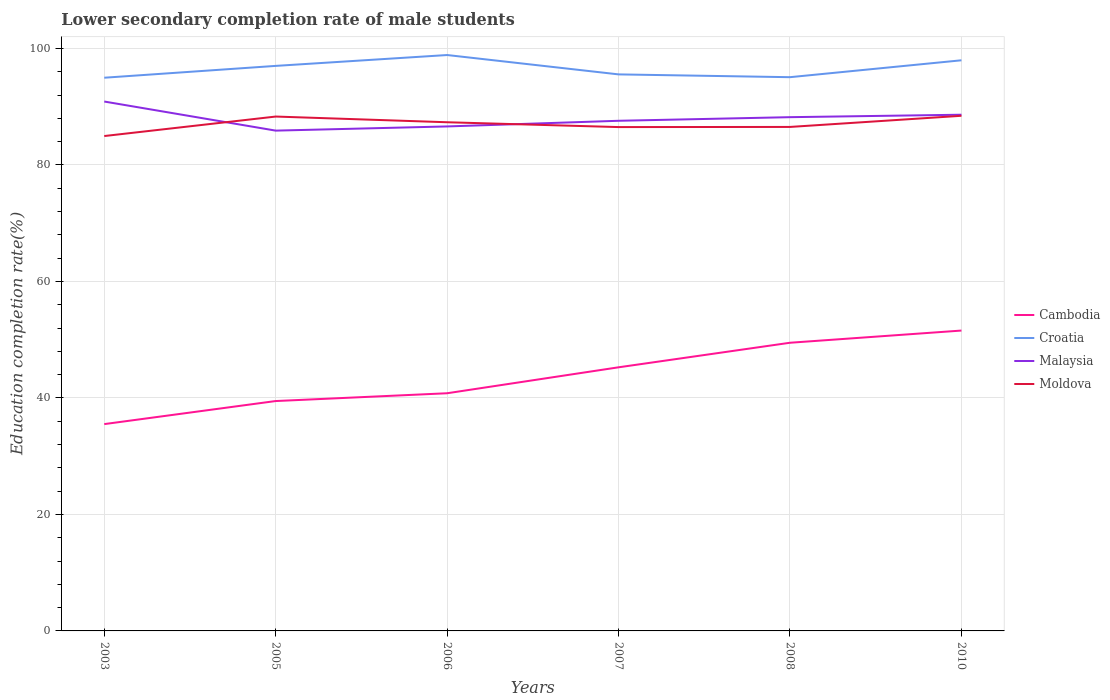How many different coloured lines are there?
Keep it short and to the point. 4. Does the line corresponding to Croatia intersect with the line corresponding to Malaysia?
Give a very brief answer. No. Across all years, what is the maximum lower secondary completion rate of male students in Cambodia?
Keep it short and to the point. 35.51. In which year was the lower secondary completion rate of male students in Croatia maximum?
Provide a short and direct response. 2003. What is the total lower secondary completion rate of male students in Cambodia in the graph?
Your response must be concise. -3.96. What is the difference between the highest and the second highest lower secondary completion rate of male students in Malaysia?
Ensure brevity in your answer.  4.99. Is the lower secondary completion rate of male students in Cambodia strictly greater than the lower secondary completion rate of male students in Malaysia over the years?
Provide a short and direct response. Yes. How many years are there in the graph?
Offer a very short reply. 6. Does the graph contain any zero values?
Offer a very short reply. No. Does the graph contain grids?
Make the answer very short. Yes. What is the title of the graph?
Your answer should be very brief. Lower secondary completion rate of male students. What is the label or title of the X-axis?
Your answer should be very brief. Years. What is the label or title of the Y-axis?
Offer a very short reply. Education completion rate(%). What is the Education completion rate(%) in Cambodia in 2003?
Give a very brief answer. 35.51. What is the Education completion rate(%) of Croatia in 2003?
Provide a succinct answer. 94.98. What is the Education completion rate(%) in Malaysia in 2003?
Give a very brief answer. 90.9. What is the Education completion rate(%) of Moldova in 2003?
Make the answer very short. 84.97. What is the Education completion rate(%) of Cambodia in 2005?
Give a very brief answer. 39.47. What is the Education completion rate(%) in Croatia in 2005?
Keep it short and to the point. 97.02. What is the Education completion rate(%) in Malaysia in 2005?
Your answer should be very brief. 85.9. What is the Education completion rate(%) in Moldova in 2005?
Offer a very short reply. 88.32. What is the Education completion rate(%) of Cambodia in 2006?
Make the answer very short. 40.81. What is the Education completion rate(%) of Croatia in 2006?
Offer a very short reply. 98.88. What is the Education completion rate(%) in Malaysia in 2006?
Provide a succinct answer. 86.62. What is the Education completion rate(%) of Moldova in 2006?
Your response must be concise. 87.34. What is the Education completion rate(%) of Cambodia in 2007?
Ensure brevity in your answer.  45.26. What is the Education completion rate(%) in Croatia in 2007?
Your answer should be very brief. 95.56. What is the Education completion rate(%) of Malaysia in 2007?
Keep it short and to the point. 87.59. What is the Education completion rate(%) of Moldova in 2007?
Your answer should be compact. 86.51. What is the Education completion rate(%) in Cambodia in 2008?
Ensure brevity in your answer.  49.48. What is the Education completion rate(%) in Croatia in 2008?
Give a very brief answer. 95.08. What is the Education completion rate(%) of Malaysia in 2008?
Offer a very short reply. 88.21. What is the Education completion rate(%) of Moldova in 2008?
Make the answer very short. 86.53. What is the Education completion rate(%) of Cambodia in 2010?
Keep it short and to the point. 51.57. What is the Education completion rate(%) of Croatia in 2010?
Make the answer very short. 97.98. What is the Education completion rate(%) in Malaysia in 2010?
Your response must be concise. 88.63. What is the Education completion rate(%) in Moldova in 2010?
Offer a very short reply. 88.45. Across all years, what is the maximum Education completion rate(%) of Cambodia?
Keep it short and to the point. 51.57. Across all years, what is the maximum Education completion rate(%) of Croatia?
Your answer should be very brief. 98.88. Across all years, what is the maximum Education completion rate(%) of Malaysia?
Provide a succinct answer. 90.9. Across all years, what is the maximum Education completion rate(%) of Moldova?
Give a very brief answer. 88.45. Across all years, what is the minimum Education completion rate(%) of Cambodia?
Provide a succinct answer. 35.51. Across all years, what is the minimum Education completion rate(%) in Croatia?
Your response must be concise. 94.98. Across all years, what is the minimum Education completion rate(%) in Malaysia?
Offer a terse response. 85.9. Across all years, what is the minimum Education completion rate(%) in Moldova?
Your answer should be very brief. 84.97. What is the total Education completion rate(%) of Cambodia in the graph?
Offer a terse response. 262.1. What is the total Education completion rate(%) of Croatia in the graph?
Give a very brief answer. 579.49. What is the total Education completion rate(%) in Malaysia in the graph?
Your answer should be very brief. 527.85. What is the total Education completion rate(%) of Moldova in the graph?
Offer a very short reply. 522.12. What is the difference between the Education completion rate(%) of Cambodia in 2003 and that in 2005?
Give a very brief answer. -3.96. What is the difference between the Education completion rate(%) in Croatia in 2003 and that in 2005?
Your answer should be very brief. -2.03. What is the difference between the Education completion rate(%) in Malaysia in 2003 and that in 2005?
Provide a succinct answer. 4.99. What is the difference between the Education completion rate(%) in Moldova in 2003 and that in 2005?
Make the answer very short. -3.35. What is the difference between the Education completion rate(%) in Cambodia in 2003 and that in 2006?
Provide a short and direct response. -5.3. What is the difference between the Education completion rate(%) of Croatia in 2003 and that in 2006?
Offer a terse response. -3.9. What is the difference between the Education completion rate(%) in Malaysia in 2003 and that in 2006?
Give a very brief answer. 4.28. What is the difference between the Education completion rate(%) in Moldova in 2003 and that in 2006?
Keep it short and to the point. -2.37. What is the difference between the Education completion rate(%) of Cambodia in 2003 and that in 2007?
Offer a terse response. -9.75. What is the difference between the Education completion rate(%) of Croatia in 2003 and that in 2007?
Keep it short and to the point. -0.57. What is the difference between the Education completion rate(%) of Malaysia in 2003 and that in 2007?
Provide a short and direct response. 3.3. What is the difference between the Education completion rate(%) of Moldova in 2003 and that in 2007?
Offer a very short reply. -1.54. What is the difference between the Education completion rate(%) of Cambodia in 2003 and that in 2008?
Give a very brief answer. -13.97. What is the difference between the Education completion rate(%) in Croatia in 2003 and that in 2008?
Your response must be concise. -0.09. What is the difference between the Education completion rate(%) of Malaysia in 2003 and that in 2008?
Give a very brief answer. 2.68. What is the difference between the Education completion rate(%) in Moldova in 2003 and that in 2008?
Keep it short and to the point. -1.56. What is the difference between the Education completion rate(%) in Cambodia in 2003 and that in 2010?
Ensure brevity in your answer.  -16.06. What is the difference between the Education completion rate(%) of Croatia in 2003 and that in 2010?
Your answer should be very brief. -2.99. What is the difference between the Education completion rate(%) in Malaysia in 2003 and that in 2010?
Ensure brevity in your answer.  2.26. What is the difference between the Education completion rate(%) of Moldova in 2003 and that in 2010?
Offer a terse response. -3.48. What is the difference between the Education completion rate(%) in Cambodia in 2005 and that in 2006?
Give a very brief answer. -1.34. What is the difference between the Education completion rate(%) of Croatia in 2005 and that in 2006?
Provide a short and direct response. -1.86. What is the difference between the Education completion rate(%) of Malaysia in 2005 and that in 2006?
Provide a short and direct response. -0.72. What is the difference between the Education completion rate(%) of Moldova in 2005 and that in 2006?
Your answer should be compact. 0.98. What is the difference between the Education completion rate(%) of Cambodia in 2005 and that in 2007?
Offer a terse response. -5.79. What is the difference between the Education completion rate(%) of Croatia in 2005 and that in 2007?
Your answer should be very brief. 1.46. What is the difference between the Education completion rate(%) of Malaysia in 2005 and that in 2007?
Ensure brevity in your answer.  -1.69. What is the difference between the Education completion rate(%) of Moldova in 2005 and that in 2007?
Your answer should be compact. 1.81. What is the difference between the Education completion rate(%) of Cambodia in 2005 and that in 2008?
Offer a terse response. -10.01. What is the difference between the Education completion rate(%) of Croatia in 2005 and that in 2008?
Give a very brief answer. 1.94. What is the difference between the Education completion rate(%) in Malaysia in 2005 and that in 2008?
Your answer should be compact. -2.31. What is the difference between the Education completion rate(%) of Moldova in 2005 and that in 2008?
Offer a very short reply. 1.78. What is the difference between the Education completion rate(%) in Cambodia in 2005 and that in 2010?
Offer a terse response. -12.1. What is the difference between the Education completion rate(%) of Croatia in 2005 and that in 2010?
Offer a very short reply. -0.96. What is the difference between the Education completion rate(%) in Malaysia in 2005 and that in 2010?
Your response must be concise. -2.73. What is the difference between the Education completion rate(%) of Moldova in 2005 and that in 2010?
Your answer should be compact. -0.13. What is the difference between the Education completion rate(%) in Cambodia in 2006 and that in 2007?
Keep it short and to the point. -4.45. What is the difference between the Education completion rate(%) of Croatia in 2006 and that in 2007?
Your answer should be compact. 3.32. What is the difference between the Education completion rate(%) of Malaysia in 2006 and that in 2007?
Your answer should be very brief. -0.97. What is the difference between the Education completion rate(%) in Moldova in 2006 and that in 2007?
Offer a very short reply. 0.83. What is the difference between the Education completion rate(%) of Cambodia in 2006 and that in 2008?
Your answer should be compact. -8.67. What is the difference between the Education completion rate(%) of Croatia in 2006 and that in 2008?
Your response must be concise. 3.8. What is the difference between the Education completion rate(%) of Malaysia in 2006 and that in 2008?
Your answer should be compact. -1.59. What is the difference between the Education completion rate(%) of Moldova in 2006 and that in 2008?
Provide a short and direct response. 0.8. What is the difference between the Education completion rate(%) of Cambodia in 2006 and that in 2010?
Provide a short and direct response. -10.77. What is the difference between the Education completion rate(%) in Croatia in 2006 and that in 2010?
Offer a very short reply. 0.9. What is the difference between the Education completion rate(%) in Malaysia in 2006 and that in 2010?
Make the answer very short. -2.01. What is the difference between the Education completion rate(%) in Moldova in 2006 and that in 2010?
Your answer should be compact. -1.11. What is the difference between the Education completion rate(%) in Cambodia in 2007 and that in 2008?
Provide a short and direct response. -4.22. What is the difference between the Education completion rate(%) in Croatia in 2007 and that in 2008?
Your answer should be compact. 0.48. What is the difference between the Education completion rate(%) in Malaysia in 2007 and that in 2008?
Make the answer very short. -0.62. What is the difference between the Education completion rate(%) of Moldova in 2007 and that in 2008?
Offer a very short reply. -0.03. What is the difference between the Education completion rate(%) in Cambodia in 2007 and that in 2010?
Your answer should be very brief. -6.31. What is the difference between the Education completion rate(%) of Croatia in 2007 and that in 2010?
Provide a short and direct response. -2.42. What is the difference between the Education completion rate(%) of Malaysia in 2007 and that in 2010?
Your answer should be compact. -1.04. What is the difference between the Education completion rate(%) of Moldova in 2007 and that in 2010?
Ensure brevity in your answer.  -1.94. What is the difference between the Education completion rate(%) in Cambodia in 2008 and that in 2010?
Provide a short and direct response. -2.09. What is the difference between the Education completion rate(%) in Croatia in 2008 and that in 2010?
Offer a very short reply. -2.9. What is the difference between the Education completion rate(%) in Malaysia in 2008 and that in 2010?
Provide a succinct answer. -0.42. What is the difference between the Education completion rate(%) in Moldova in 2008 and that in 2010?
Ensure brevity in your answer.  -1.91. What is the difference between the Education completion rate(%) of Cambodia in 2003 and the Education completion rate(%) of Croatia in 2005?
Give a very brief answer. -61.5. What is the difference between the Education completion rate(%) in Cambodia in 2003 and the Education completion rate(%) in Malaysia in 2005?
Keep it short and to the point. -50.39. What is the difference between the Education completion rate(%) of Cambodia in 2003 and the Education completion rate(%) of Moldova in 2005?
Your answer should be very brief. -52.81. What is the difference between the Education completion rate(%) in Croatia in 2003 and the Education completion rate(%) in Malaysia in 2005?
Offer a very short reply. 9.08. What is the difference between the Education completion rate(%) in Croatia in 2003 and the Education completion rate(%) in Moldova in 2005?
Keep it short and to the point. 6.67. What is the difference between the Education completion rate(%) in Malaysia in 2003 and the Education completion rate(%) in Moldova in 2005?
Ensure brevity in your answer.  2.58. What is the difference between the Education completion rate(%) in Cambodia in 2003 and the Education completion rate(%) in Croatia in 2006?
Offer a very short reply. -63.37. What is the difference between the Education completion rate(%) in Cambodia in 2003 and the Education completion rate(%) in Malaysia in 2006?
Your response must be concise. -51.11. What is the difference between the Education completion rate(%) of Cambodia in 2003 and the Education completion rate(%) of Moldova in 2006?
Your answer should be compact. -51.83. What is the difference between the Education completion rate(%) in Croatia in 2003 and the Education completion rate(%) in Malaysia in 2006?
Provide a succinct answer. 8.36. What is the difference between the Education completion rate(%) in Croatia in 2003 and the Education completion rate(%) in Moldova in 2006?
Your answer should be very brief. 7.64. What is the difference between the Education completion rate(%) of Malaysia in 2003 and the Education completion rate(%) of Moldova in 2006?
Give a very brief answer. 3.56. What is the difference between the Education completion rate(%) in Cambodia in 2003 and the Education completion rate(%) in Croatia in 2007?
Make the answer very short. -60.05. What is the difference between the Education completion rate(%) in Cambodia in 2003 and the Education completion rate(%) in Malaysia in 2007?
Your answer should be very brief. -52.08. What is the difference between the Education completion rate(%) of Cambodia in 2003 and the Education completion rate(%) of Moldova in 2007?
Give a very brief answer. -51. What is the difference between the Education completion rate(%) in Croatia in 2003 and the Education completion rate(%) in Malaysia in 2007?
Ensure brevity in your answer.  7.39. What is the difference between the Education completion rate(%) of Croatia in 2003 and the Education completion rate(%) of Moldova in 2007?
Ensure brevity in your answer.  8.47. What is the difference between the Education completion rate(%) of Malaysia in 2003 and the Education completion rate(%) of Moldova in 2007?
Keep it short and to the point. 4.39. What is the difference between the Education completion rate(%) of Cambodia in 2003 and the Education completion rate(%) of Croatia in 2008?
Offer a terse response. -59.57. What is the difference between the Education completion rate(%) in Cambodia in 2003 and the Education completion rate(%) in Malaysia in 2008?
Your answer should be compact. -52.7. What is the difference between the Education completion rate(%) in Cambodia in 2003 and the Education completion rate(%) in Moldova in 2008?
Provide a short and direct response. -51.02. What is the difference between the Education completion rate(%) of Croatia in 2003 and the Education completion rate(%) of Malaysia in 2008?
Provide a short and direct response. 6.77. What is the difference between the Education completion rate(%) in Croatia in 2003 and the Education completion rate(%) in Moldova in 2008?
Provide a short and direct response. 8.45. What is the difference between the Education completion rate(%) of Malaysia in 2003 and the Education completion rate(%) of Moldova in 2008?
Ensure brevity in your answer.  4.36. What is the difference between the Education completion rate(%) in Cambodia in 2003 and the Education completion rate(%) in Croatia in 2010?
Ensure brevity in your answer.  -62.47. What is the difference between the Education completion rate(%) in Cambodia in 2003 and the Education completion rate(%) in Malaysia in 2010?
Keep it short and to the point. -53.12. What is the difference between the Education completion rate(%) in Cambodia in 2003 and the Education completion rate(%) in Moldova in 2010?
Ensure brevity in your answer.  -52.94. What is the difference between the Education completion rate(%) of Croatia in 2003 and the Education completion rate(%) of Malaysia in 2010?
Give a very brief answer. 6.35. What is the difference between the Education completion rate(%) of Croatia in 2003 and the Education completion rate(%) of Moldova in 2010?
Offer a very short reply. 6.53. What is the difference between the Education completion rate(%) in Malaysia in 2003 and the Education completion rate(%) in Moldova in 2010?
Offer a very short reply. 2.45. What is the difference between the Education completion rate(%) of Cambodia in 2005 and the Education completion rate(%) of Croatia in 2006?
Your answer should be very brief. -59.41. What is the difference between the Education completion rate(%) in Cambodia in 2005 and the Education completion rate(%) in Malaysia in 2006?
Ensure brevity in your answer.  -47.15. What is the difference between the Education completion rate(%) in Cambodia in 2005 and the Education completion rate(%) in Moldova in 2006?
Your response must be concise. -47.87. What is the difference between the Education completion rate(%) of Croatia in 2005 and the Education completion rate(%) of Malaysia in 2006?
Offer a terse response. 10.4. What is the difference between the Education completion rate(%) of Croatia in 2005 and the Education completion rate(%) of Moldova in 2006?
Your answer should be very brief. 9.68. What is the difference between the Education completion rate(%) of Malaysia in 2005 and the Education completion rate(%) of Moldova in 2006?
Provide a short and direct response. -1.44. What is the difference between the Education completion rate(%) of Cambodia in 2005 and the Education completion rate(%) of Croatia in 2007?
Your response must be concise. -56.09. What is the difference between the Education completion rate(%) of Cambodia in 2005 and the Education completion rate(%) of Malaysia in 2007?
Your answer should be compact. -48.12. What is the difference between the Education completion rate(%) in Cambodia in 2005 and the Education completion rate(%) in Moldova in 2007?
Offer a terse response. -47.04. What is the difference between the Education completion rate(%) of Croatia in 2005 and the Education completion rate(%) of Malaysia in 2007?
Provide a short and direct response. 9.42. What is the difference between the Education completion rate(%) of Croatia in 2005 and the Education completion rate(%) of Moldova in 2007?
Keep it short and to the point. 10.51. What is the difference between the Education completion rate(%) of Malaysia in 2005 and the Education completion rate(%) of Moldova in 2007?
Offer a terse response. -0.61. What is the difference between the Education completion rate(%) in Cambodia in 2005 and the Education completion rate(%) in Croatia in 2008?
Provide a succinct answer. -55.61. What is the difference between the Education completion rate(%) in Cambodia in 2005 and the Education completion rate(%) in Malaysia in 2008?
Make the answer very short. -48.74. What is the difference between the Education completion rate(%) of Cambodia in 2005 and the Education completion rate(%) of Moldova in 2008?
Offer a terse response. -47.06. What is the difference between the Education completion rate(%) in Croatia in 2005 and the Education completion rate(%) in Malaysia in 2008?
Offer a terse response. 8.8. What is the difference between the Education completion rate(%) of Croatia in 2005 and the Education completion rate(%) of Moldova in 2008?
Provide a short and direct response. 10.48. What is the difference between the Education completion rate(%) of Malaysia in 2005 and the Education completion rate(%) of Moldova in 2008?
Make the answer very short. -0.63. What is the difference between the Education completion rate(%) of Cambodia in 2005 and the Education completion rate(%) of Croatia in 2010?
Offer a very short reply. -58.51. What is the difference between the Education completion rate(%) of Cambodia in 2005 and the Education completion rate(%) of Malaysia in 2010?
Your answer should be very brief. -49.16. What is the difference between the Education completion rate(%) of Cambodia in 2005 and the Education completion rate(%) of Moldova in 2010?
Your answer should be compact. -48.98. What is the difference between the Education completion rate(%) in Croatia in 2005 and the Education completion rate(%) in Malaysia in 2010?
Provide a short and direct response. 8.38. What is the difference between the Education completion rate(%) in Croatia in 2005 and the Education completion rate(%) in Moldova in 2010?
Provide a short and direct response. 8.57. What is the difference between the Education completion rate(%) in Malaysia in 2005 and the Education completion rate(%) in Moldova in 2010?
Keep it short and to the point. -2.55. What is the difference between the Education completion rate(%) in Cambodia in 2006 and the Education completion rate(%) in Croatia in 2007?
Provide a succinct answer. -54.75. What is the difference between the Education completion rate(%) in Cambodia in 2006 and the Education completion rate(%) in Malaysia in 2007?
Your answer should be compact. -46.78. What is the difference between the Education completion rate(%) of Cambodia in 2006 and the Education completion rate(%) of Moldova in 2007?
Give a very brief answer. -45.7. What is the difference between the Education completion rate(%) in Croatia in 2006 and the Education completion rate(%) in Malaysia in 2007?
Provide a succinct answer. 11.29. What is the difference between the Education completion rate(%) in Croatia in 2006 and the Education completion rate(%) in Moldova in 2007?
Provide a short and direct response. 12.37. What is the difference between the Education completion rate(%) in Malaysia in 2006 and the Education completion rate(%) in Moldova in 2007?
Your answer should be very brief. 0.11. What is the difference between the Education completion rate(%) of Cambodia in 2006 and the Education completion rate(%) of Croatia in 2008?
Make the answer very short. -54.27. What is the difference between the Education completion rate(%) in Cambodia in 2006 and the Education completion rate(%) in Malaysia in 2008?
Keep it short and to the point. -47.4. What is the difference between the Education completion rate(%) of Cambodia in 2006 and the Education completion rate(%) of Moldova in 2008?
Provide a succinct answer. -45.73. What is the difference between the Education completion rate(%) of Croatia in 2006 and the Education completion rate(%) of Malaysia in 2008?
Offer a terse response. 10.67. What is the difference between the Education completion rate(%) of Croatia in 2006 and the Education completion rate(%) of Moldova in 2008?
Your answer should be very brief. 12.35. What is the difference between the Education completion rate(%) in Malaysia in 2006 and the Education completion rate(%) in Moldova in 2008?
Give a very brief answer. 0.08. What is the difference between the Education completion rate(%) in Cambodia in 2006 and the Education completion rate(%) in Croatia in 2010?
Provide a short and direct response. -57.17. What is the difference between the Education completion rate(%) of Cambodia in 2006 and the Education completion rate(%) of Malaysia in 2010?
Make the answer very short. -47.82. What is the difference between the Education completion rate(%) of Cambodia in 2006 and the Education completion rate(%) of Moldova in 2010?
Your answer should be very brief. -47.64. What is the difference between the Education completion rate(%) in Croatia in 2006 and the Education completion rate(%) in Malaysia in 2010?
Provide a succinct answer. 10.25. What is the difference between the Education completion rate(%) in Croatia in 2006 and the Education completion rate(%) in Moldova in 2010?
Provide a succinct answer. 10.43. What is the difference between the Education completion rate(%) of Malaysia in 2006 and the Education completion rate(%) of Moldova in 2010?
Give a very brief answer. -1.83. What is the difference between the Education completion rate(%) in Cambodia in 2007 and the Education completion rate(%) in Croatia in 2008?
Ensure brevity in your answer.  -49.81. What is the difference between the Education completion rate(%) of Cambodia in 2007 and the Education completion rate(%) of Malaysia in 2008?
Your answer should be compact. -42.95. What is the difference between the Education completion rate(%) in Cambodia in 2007 and the Education completion rate(%) in Moldova in 2008?
Provide a succinct answer. -41.27. What is the difference between the Education completion rate(%) in Croatia in 2007 and the Education completion rate(%) in Malaysia in 2008?
Your answer should be very brief. 7.35. What is the difference between the Education completion rate(%) in Croatia in 2007 and the Education completion rate(%) in Moldova in 2008?
Ensure brevity in your answer.  9.02. What is the difference between the Education completion rate(%) in Malaysia in 2007 and the Education completion rate(%) in Moldova in 2008?
Offer a terse response. 1.06. What is the difference between the Education completion rate(%) in Cambodia in 2007 and the Education completion rate(%) in Croatia in 2010?
Offer a very short reply. -52.71. What is the difference between the Education completion rate(%) in Cambodia in 2007 and the Education completion rate(%) in Malaysia in 2010?
Provide a short and direct response. -43.37. What is the difference between the Education completion rate(%) of Cambodia in 2007 and the Education completion rate(%) of Moldova in 2010?
Offer a terse response. -43.19. What is the difference between the Education completion rate(%) of Croatia in 2007 and the Education completion rate(%) of Malaysia in 2010?
Keep it short and to the point. 6.93. What is the difference between the Education completion rate(%) in Croatia in 2007 and the Education completion rate(%) in Moldova in 2010?
Ensure brevity in your answer.  7.11. What is the difference between the Education completion rate(%) in Malaysia in 2007 and the Education completion rate(%) in Moldova in 2010?
Ensure brevity in your answer.  -0.86. What is the difference between the Education completion rate(%) in Cambodia in 2008 and the Education completion rate(%) in Croatia in 2010?
Ensure brevity in your answer.  -48.5. What is the difference between the Education completion rate(%) in Cambodia in 2008 and the Education completion rate(%) in Malaysia in 2010?
Give a very brief answer. -39.15. What is the difference between the Education completion rate(%) of Cambodia in 2008 and the Education completion rate(%) of Moldova in 2010?
Give a very brief answer. -38.97. What is the difference between the Education completion rate(%) in Croatia in 2008 and the Education completion rate(%) in Malaysia in 2010?
Offer a terse response. 6.45. What is the difference between the Education completion rate(%) in Croatia in 2008 and the Education completion rate(%) in Moldova in 2010?
Provide a succinct answer. 6.63. What is the difference between the Education completion rate(%) in Malaysia in 2008 and the Education completion rate(%) in Moldova in 2010?
Keep it short and to the point. -0.24. What is the average Education completion rate(%) of Cambodia per year?
Give a very brief answer. 43.68. What is the average Education completion rate(%) of Croatia per year?
Give a very brief answer. 96.58. What is the average Education completion rate(%) of Malaysia per year?
Your answer should be very brief. 87.97. What is the average Education completion rate(%) in Moldova per year?
Make the answer very short. 87.02. In the year 2003, what is the difference between the Education completion rate(%) in Cambodia and Education completion rate(%) in Croatia?
Give a very brief answer. -59.47. In the year 2003, what is the difference between the Education completion rate(%) of Cambodia and Education completion rate(%) of Malaysia?
Make the answer very short. -55.38. In the year 2003, what is the difference between the Education completion rate(%) of Cambodia and Education completion rate(%) of Moldova?
Provide a short and direct response. -49.46. In the year 2003, what is the difference between the Education completion rate(%) of Croatia and Education completion rate(%) of Malaysia?
Make the answer very short. 4.09. In the year 2003, what is the difference between the Education completion rate(%) of Croatia and Education completion rate(%) of Moldova?
Your answer should be compact. 10.01. In the year 2003, what is the difference between the Education completion rate(%) of Malaysia and Education completion rate(%) of Moldova?
Make the answer very short. 5.93. In the year 2005, what is the difference between the Education completion rate(%) of Cambodia and Education completion rate(%) of Croatia?
Offer a very short reply. -57.55. In the year 2005, what is the difference between the Education completion rate(%) of Cambodia and Education completion rate(%) of Malaysia?
Provide a short and direct response. -46.43. In the year 2005, what is the difference between the Education completion rate(%) of Cambodia and Education completion rate(%) of Moldova?
Ensure brevity in your answer.  -48.85. In the year 2005, what is the difference between the Education completion rate(%) of Croatia and Education completion rate(%) of Malaysia?
Keep it short and to the point. 11.11. In the year 2005, what is the difference between the Education completion rate(%) of Croatia and Education completion rate(%) of Moldova?
Your answer should be very brief. 8.7. In the year 2005, what is the difference between the Education completion rate(%) in Malaysia and Education completion rate(%) in Moldova?
Give a very brief answer. -2.42. In the year 2006, what is the difference between the Education completion rate(%) of Cambodia and Education completion rate(%) of Croatia?
Ensure brevity in your answer.  -58.07. In the year 2006, what is the difference between the Education completion rate(%) in Cambodia and Education completion rate(%) in Malaysia?
Your answer should be very brief. -45.81. In the year 2006, what is the difference between the Education completion rate(%) of Cambodia and Education completion rate(%) of Moldova?
Make the answer very short. -46.53. In the year 2006, what is the difference between the Education completion rate(%) in Croatia and Education completion rate(%) in Malaysia?
Your answer should be very brief. 12.26. In the year 2006, what is the difference between the Education completion rate(%) of Croatia and Education completion rate(%) of Moldova?
Your response must be concise. 11.54. In the year 2006, what is the difference between the Education completion rate(%) of Malaysia and Education completion rate(%) of Moldova?
Provide a succinct answer. -0.72. In the year 2007, what is the difference between the Education completion rate(%) of Cambodia and Education completion rate(%) of Croatia?
Give a very brief answer. -50.29. In the year 2007, what is the difference between the Education completion rate(%) of Cambodia and Education completion rate(%) of Malaysia?
Provide a short and direct response. -42.33. In the year 2007, what is the difference between the Education completion rate(%) of Cambodia and Education completion rate(%) of Moldova?
Your response must be concise. -41.25. In the year 2007, what is the difference between the Education completion rate(%) of Croatia and Education completion rate(%) of Malaysia?
Keep it short and to the point. 7.97. In the year 2007, what is the difference between the Education completion rate(%) in Croatia and Education completion rate(%) in Moldova?
Make the answer very short. 9.05. In the year 2007, what is the difference between the Education completion rate(%) in Malaysia and Education completion rate(%) in Moldova?
Your answer should be compact. 1.08. In the year 2008, what is the difference between the Education completion rate(%) in Cambodia and Education completion rate(%) in Croatia?
Give a very brief answer. -45.6. In the year 2008, what is the difference between the Education completion rate(%) in Cambodia and Education completion rate(%) in Malaysia?
Keep it short and to the point. -38.73. In the year 2008, what is the difference between the Education completion rate(%) of Cambodia and Education completion rate(%) of Moldova?
Provide a succinct answer. -37.06. In the year 2008, what is the difference between the Education completion rate(%) in Croatia and Education completion rate(%) in Malaysia?
Make the answer very short. 6.87. In the year 2008, what is the difference between the Education completion rate(%) in Croatia and Education completion rate(%) in Moldova?
Offer a terse response. 8.54. In the year 2008, what is the difference between the Education completion rate(%) in Malaysia and Education completion rate(%) in Moldova?
Ensure brevity in your answer.  1.68. In the year 2010, what is the difference between the Education completion rate(%) of Cambodia and Education completion rate(%) of Croatia?
Keep it short and to the point. -46.4. In the year 2010, what is the difference between the Education completion rate(%) in Cambodia and Education completion rate(%) in Malaysia?
Your answer should be very brief. -37.06. In the year 2010, what is the difference between the Education completion rate(%) of Cambodia and Education completion rate(%) of Moldova?
Your answer should be compact. -36.88. In the year 2010, what is the difference between the Education completion rate(%) in Croatia and Education completion rate(%) in Malaysia?
Ensure brevity in your answer.  9.35. In the year 2010, what is the difference between the Education completion rate(%) of Croatia and Education completion rate(%) of Moldova?
Your response must be concise. 9.53. In the year 2010, what is the difference between the Education completion rate(%) of Malaysia and Education completion rate(%) of Moldova?
Make the answer very short. 0.18. What is the ratio of the Education completion rate(%) of Cambodia in 2003 to that in 2005?
Your response must be concise. 0.9. What is the ratio of the Education completion rate(%) in Malaysia in 2003 to that in 2005?
Make the answer very short. 1.06. What is the ratio of the Education completion rate(%) of Moldova in 2003 to that in 2005?
Your response must be concise. 0.96. What is the ratio of the Education completion rate(%) of Cambodia in 2003 to that in 2006?
Offer a very short reply. 0.87. What is the ratio of the Education completion rate(%) in Croatia in 2003 to that in 2006?
Your answer should be very brief. 0.96. What is the ratio of the Education completion rate(%) of Malaysia in 2003 to that in 2006?
Provide a short and direct response. 1.05. What is the ratio of the Education completion rate(%) in Moldova in 2003 to that in 2006?
Offer a very short reply. 0.97. What is the ratio of the Education completion rate(%) in Cambodia in 2003 to that in 2007?
Offer a very short reply. 0.78. What is the ratio of the Education completion rate(%) of Croatia in 2003 to that in 2007?
Your response must be concise. 0.99. What is the ratio of the Education completion rate(%) of Malaysia in 2003 to that in 2007?
Your answer should be very brief. 1.04. What is the ratio of the Education completion rate(%) in Moldova in 2003 to that in 2007?
Offer a terse response. 0.98. What is the ratio of the Education completion rate(%) in Cambodia in 2003 to that in 2008?
Give a very brief answer. 0.72. What is the ratio of the Education completion rate(%) in Croatia in 2003 to that in 2008?
Provide a succinct answer. 1. What is the ratio of the Education completion rate(%) in Malaysia in 2003 to that in 2008?
Provide a short and direct response. 1.03. What is the ratio of the Education completion rate(%) in Moldova in 2003 to that in 2008?
Offer a very short reply. 0.98. What is the ratio of the Education completion rate(%) in Cambodia in 2003 to that in 2010?
Make the answer very short. 0.69. What is the ratio of the Education completion rate(%) in Croatia in 2003 to that in 2010?
Make the answer very short. 0.97. What is the ratio of the Education completion rate(%) in Malaysia in 2003 to that in 2010?
Offer a terse response. 1.03. What is the ratio of the Education completion rate(%) in Moldova in 2003 to that in 2010?
Ensure brevity in your answer.  0.96. What is the ratio of the Education completion rate(%) of Cambodia in 2005 to that in 2006?
Keep it short and to the point. 0.97. What is the ratio of the Education completion rate(%) of Croatia in 2005 to that in 2006?
Your answer should be compact. 0.98. What is the ratio of the Education completion rate(%) in Malaysia in 2005 to that in 2006?
Your answer should be very brief. 0.99. What is the ratio of the Education completion rate(%) of Moldova in 2005 to that in 2006?
Your response must be concise. 1.01. What is the ratio of the Education completion rate(%) of Cambodia in 2005 to that in 2007?
Your answer should be very brief. 0.87. What is the ratio of the Education completion rate(%) of Croatia in 2005 to that in 2007?
Your answer should be very brief. 1.02. What is the ratio of the Education completion rate(%) of Malaysia in 2005 to that in 2007?
Offer a very short reply. 0.98. What is the ratio of the Education completion rate(%) of Moldova in 2005 to that in 2007?
Keep it short and to the point. 1.02. What is the ratio of the Education completion rate(%) of Cambodia in 2005 to that in 2008?
Your answer should be compact. 0.8. What is the ratio of the Education completion rate(%) of Croatia in 2005 to that in 2008?
Keep it short and to the point. 1.02. What is the ratio of the Education completion rate(%) of Malaysia in 2005 to that in 2008?
Keep it short and to the point. 0.97. What is the ratio of the Education completion rate(%) in Moldova in 2005 to that in 2008?
Offer a terse response. 1.02. What is the ratio of the Education completion rate(%) in Cambodia in 2005 to that in 2010?
Make the answer very short. 0.77. What is the ratio of the Education completion rate(%) of Croatia in 2005 to that in 2010?
Your response must be concise. 0.99. What is the ratio of the Education completion rate(%) in Malaysia in 2005 to that in 2010?
Offer a very short reply. 0.97. What is the ratio of the Education completion rate(%) of Moldova in 2005 to that in 2010?
Provide a succinct answer. 1. What is the ratio of the Education completion rate(%) of Cambodia in 2006 to that in 2007?
Ensure brevity in your answer.  0.9. What is the ratio of the Education completion rate(%) of Croatia in 2006 to that in 2007?
Offer a terse response. 1.03. What is the ratio of the Education completion rate(%) of Malaysia in 2006 to that in 2007?
Offer a very short reply. 0.99. What is the ratio of the Education completion rate(%) in Moldova in 2006 to that in 2007?
Make the answer very short. 1.01. What is the ratio of the Education completion rate(%) of Cambodia in 2006 to that in 2008?
Provide a succinct answer. 0.82. What is the ratio of the Education completion rate(%) in Croatia in 2006 to that in 2008?
Provide a succinct answer. 1.04. What is the ratio of the Education completion rate(%) in Malaysia in 2006 to that in 2008?
Ensure brevity in your answer.  0.98. What is the ratio of the Education completion rate(%) of Moldova in 2006 to that in 2008?
Give a very brief answer. 1.01. What is the ratio of the Education completion rate(%) in Cambodia in 2006 to that in 2010?
Provide a short and direct response. 0.79. What is the ratio of the Education completion rate(%) of Croatia in 2006 to that in 2010?
Offer a very short reply. 1.01. What is the ratio of the Education completion rate(%) in Malaysia in 2006 to that in 2010?
Offer a very short reply. 0.98. What is the ratio of the Education completion rate(%) in Moldova in 2006 to that in 2010?
Offer a very short reply. 0.99. What is the ratio of the Education completion rate(%) of Cambodia in 2007 to that in 2008?
Ensure brevity in your answer.  0.91. What is the ratio of the Education completion rate(%) of Croatia in 2007 to that in 2008?
Your answer should be very brief. 1.01. What is the ratio of the Education completion rate(%) in Moldova in 2007 to that in 2008?
Ensure brevity in your answer.  1. What is the ratio of the Education completion rate(%) in Cambodia in 2007 to that in 2010?
Make the answer very short. 0.88. What is the ratio of the Education completion rate(%) of Croatia in 2007 to that in 2010?
Give a very brief answer. 0.98. What is the ratio of the Education completion rate(%) of Malaysia in 2007 to that in 2010?
Your answer should be very brief. 0.99. What is the ratio of the Education completion rate(%) of Moldova in 2007 to that in 2010?
Give a very brief answer. 0.98. What is the ratio of the Education completion rate(%) of Cambodia in 2008 to that in 2010?
Your response must be concise. 0.96. What is the ratio of the Education completion rate(%) of Croatia in 2008 to that in 2010?
Your answer should be very brief. 0.97. What is the ratio of the Education completion rate(%) in Malaysia in 2008 to that in 2010?
Your answer should be compact. 1. What is the ratio of the Education completion rate(%) of Moldova in 2008 to that in 2010?
Offer a terse response. 0.98. What is the difference between the highest and the second highest Education completion rate(%) of Cambodia?
Ensure brevity in your answer.  2.09. What is the difference between the highest and the second highest Education completion rate(%) of Croatia?
Offer a terse response. 0.9. What is the difference between the highest and the second highest Education completion rate(%) of Malaysia?
Provide a short and direct response. 2.26. What is the difference between the highest and the second highest Education completion rate(%) in Moldova?
Your answer should be compact. 0.13. What is the difference between the highest and the lowest Education completion rate(%) in Cambodia?
Keep it short and to the point. 16.06. What is the difference between the highest and the lowest Education completion rate(%) in Croatia?
Make the answer very short. 3.9. What is the difference between the highest and the lowest Education completion rate(%) in Malaysia?
Make the answer very short. 4.99. What is the difference between the highest and the lowest Education completion rate(%) of Moldova?
Offer a very short reply. 3.48. 